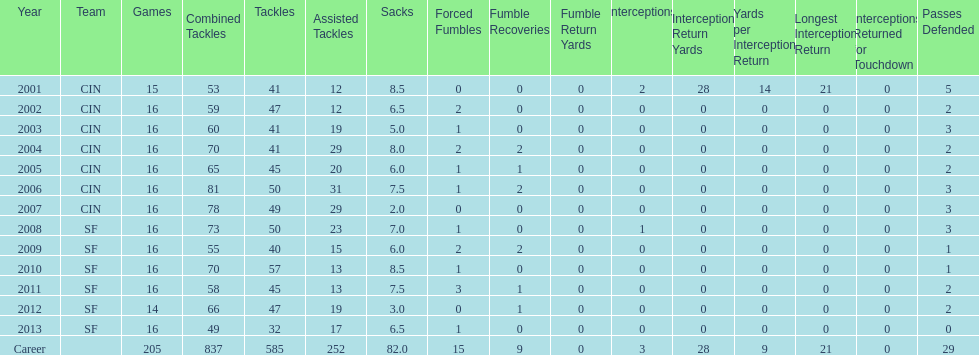How many consecutive years were there 20 or more assisted tackles? 5. 